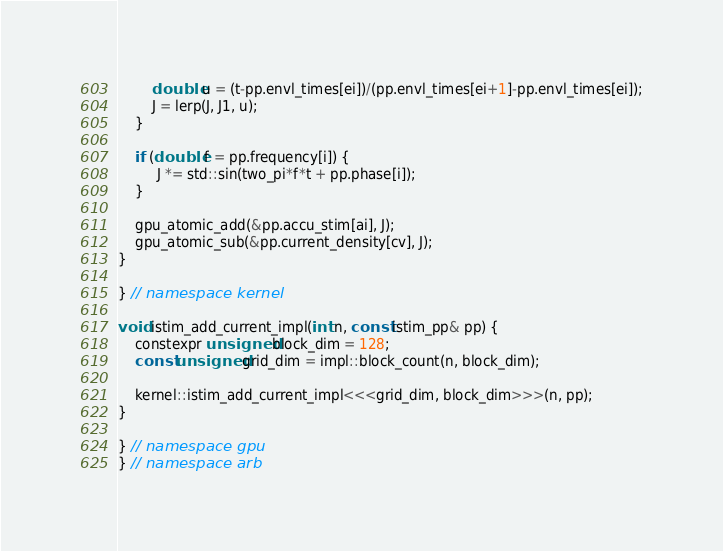Convert code to text. <code><loc_0><loc_0><loc_500><loc_500><_Cuda_>        double u = (t-pp.envl_times[ei])/(pp.envl_times[ei+1]-pp.envl_times[ei]);
        J = lerp(J, J1, u);
    }

    if (double f = pp.frequency[i]) {
         J *= std::sin(two_pi*f*t + pp.phase[i]);
    }

    gpu_atomic_add(&pp.accu_stim[ai], J);
    gpu_atomic_sub(&pp.current_density[cv], J);
}

} // namespace kernel

void istim_add_current_impl(int n, const istim_pp& pp) {
    constexpr unsigned block_dim = 128;
    const unsigned grid_dim = impl::block_count(n, block_dim);

    kernel::istim_add_current_impl<<<grid_dim, block_dim>>>(n, pp);
}

} // namespace gpu
} // namespace arb
</code> 